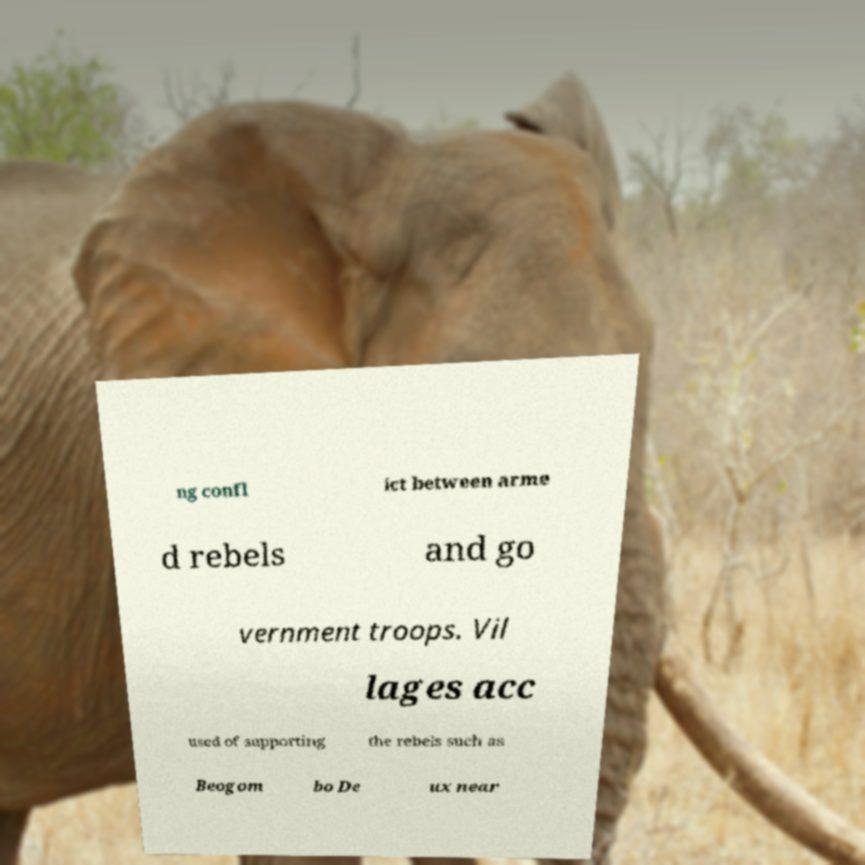Can you accurately transcribe the text from the provided image for me? ng confl ict between arme d rebels and go vernment troops. Vil lages acc used of supporting the rebels such as Beogom bo De ux near 